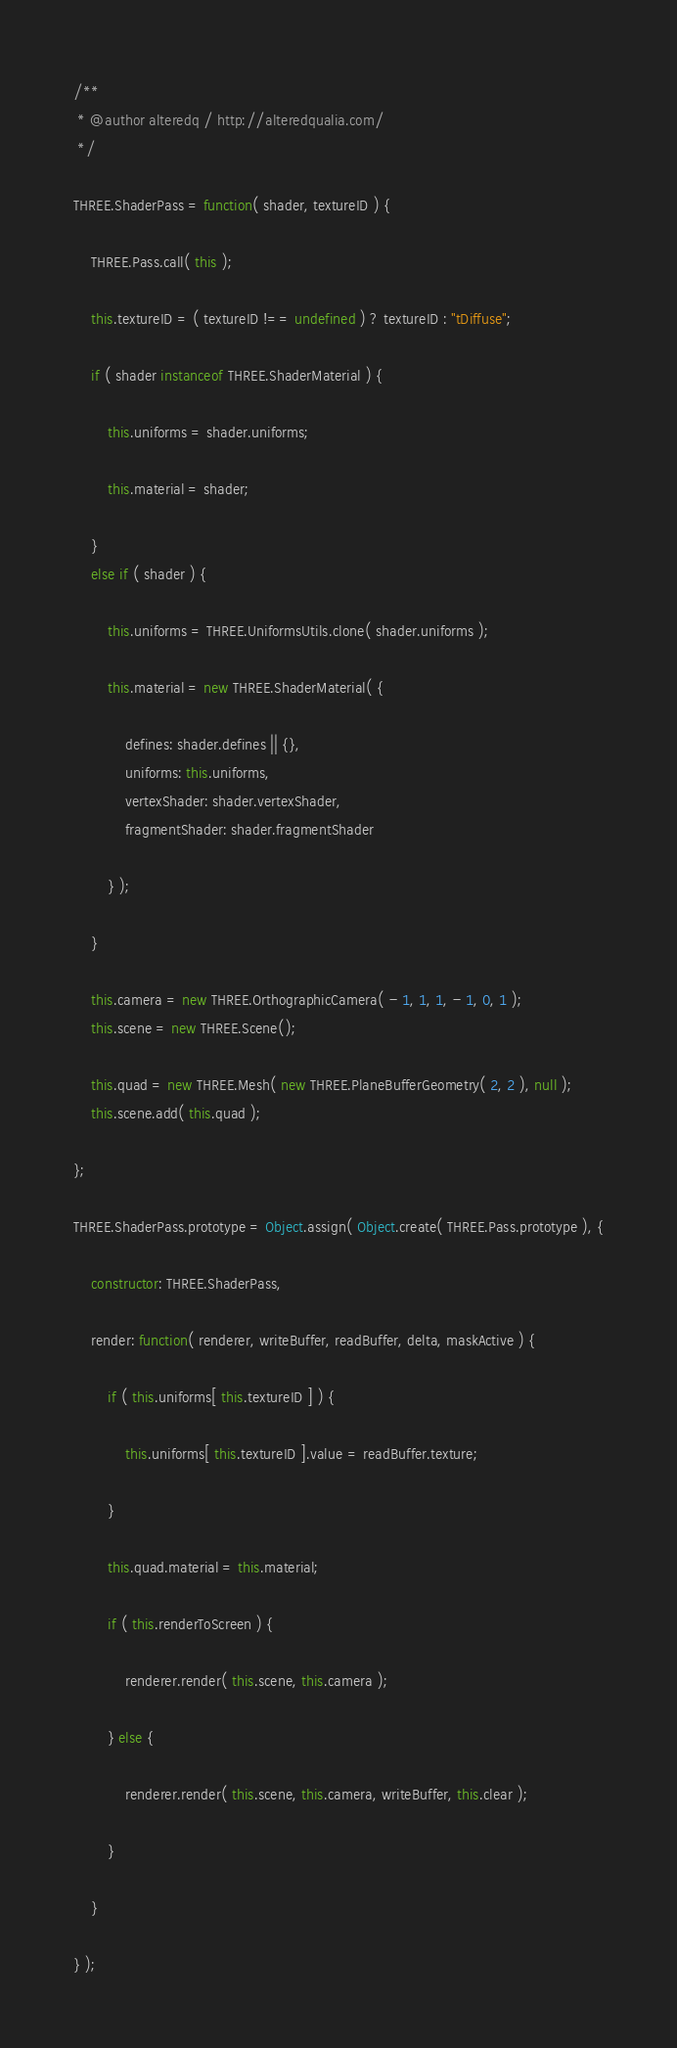Convert code to text. <code><loc_0><loc_0><loc_500><loc_500><_JavaScript_>/**
 * @author alteredq / http://alteredqualia.com/
 */

THREE.ShaderPass = function( shader, textureID ) {

	THREE.Pass.call( this );

	this.textureID = ( textureID !== undefined ) ? textureID : "tDiffuse";

	if ( shader instanceof THREE.ShaderMaterial ) {

		this.uniforms = shader.uniforms;

		this.material = shader;

	}
	else if ( shader ) {

		this.uniforms = THREE.UniformsUtils.clone( shader.uniforms );

		this.material = new THREE.ShaderMaterial( {

			defines: shader.defines || {},
			uniforms: this.uniforms,
			vertexShader: shader.vertexShader,
			fragmentShader: shader.fragmentShader

		} );

	}

	this.camera = new THREE.OrthographicCamera( - 1, 1, 1, - 1, 0, 1 );
	this.scene = new THREE.Scene();

	this.quad = new THREE.Mesh( new THREE.PlaneBufferGeometry( 2, 2 ), null );
	this.scene.add( this.quad );

};

THREE.ShaderPass.prototype = Object.assign( Object.create( THREE.Pass.prototype ), {

	constructor: THREE.ShaderPass,

	render: function( renderer, writeBuffer, readBuffer, delta, maskActive ) {

		if ( this.uniforms[ this.textureID ] ) {

			this.uniforms[ this.textureID ].value = readBuffer.texture;

		}

		this.quad.material = this.material;

		if ( this.renderToScreen ) {

			renderer.render( this.scene, this.camera );

		} else {

			renderer.render( this.scene, this.camera, writeBuffer, this.clear );

		}

	}

} );
</code> 